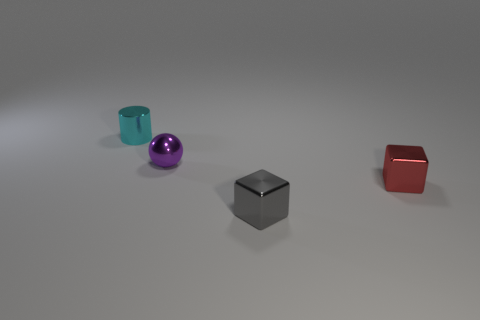There is a small sphere that is made of the same material as the tiny cylinder; what color is it? purple 